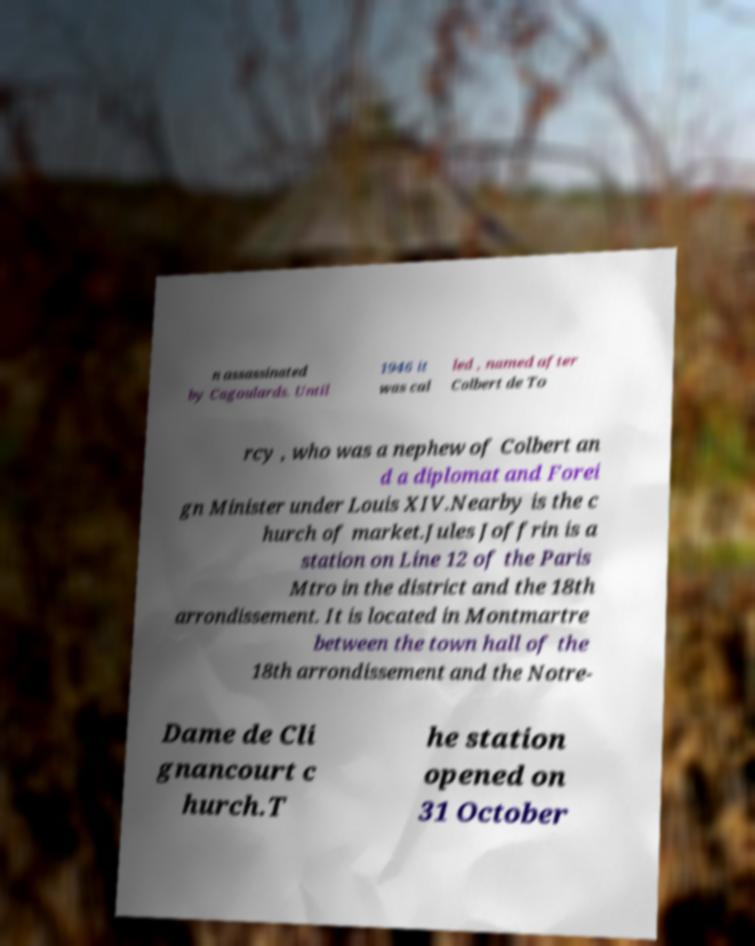Can you read and provide the text displayed in the image?This photo seems to have some interesting text. Can you extract and type it out for me? n assassinated by Cagoulards. Until 1946 it was cal led , named after Colbert de To rcy , who was a nephew of Colbert an d a diplomat and Forei gn Minister under Louis XIV.Nearby is the c hurch of market.Jules Joffrin is a station on Line 12 of the Paris Mtro in the district and the 18th arrondissement. It is located in Montmartre between the town hall of the 18th arrondissement and the Notre- Dame de Cli gnancourt c hurch.T he station opened on 31 October 